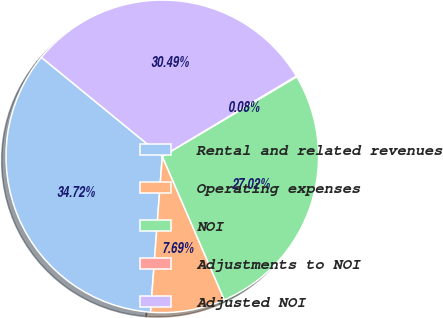Convert chart. <chart><loc_0><loc_0><loc_500><loc_500><pie_chart><fcel>Rental and related revenues<fcel>Operating expenses<fcel>NOI<fcel>Adjustments to NOI<fcel>Adjusted NOI<nl><fcel>34.72%<fcel>7.69%<fcel>27.02%<fcel>0.08%<fcel>30.49%<nl></chart> 